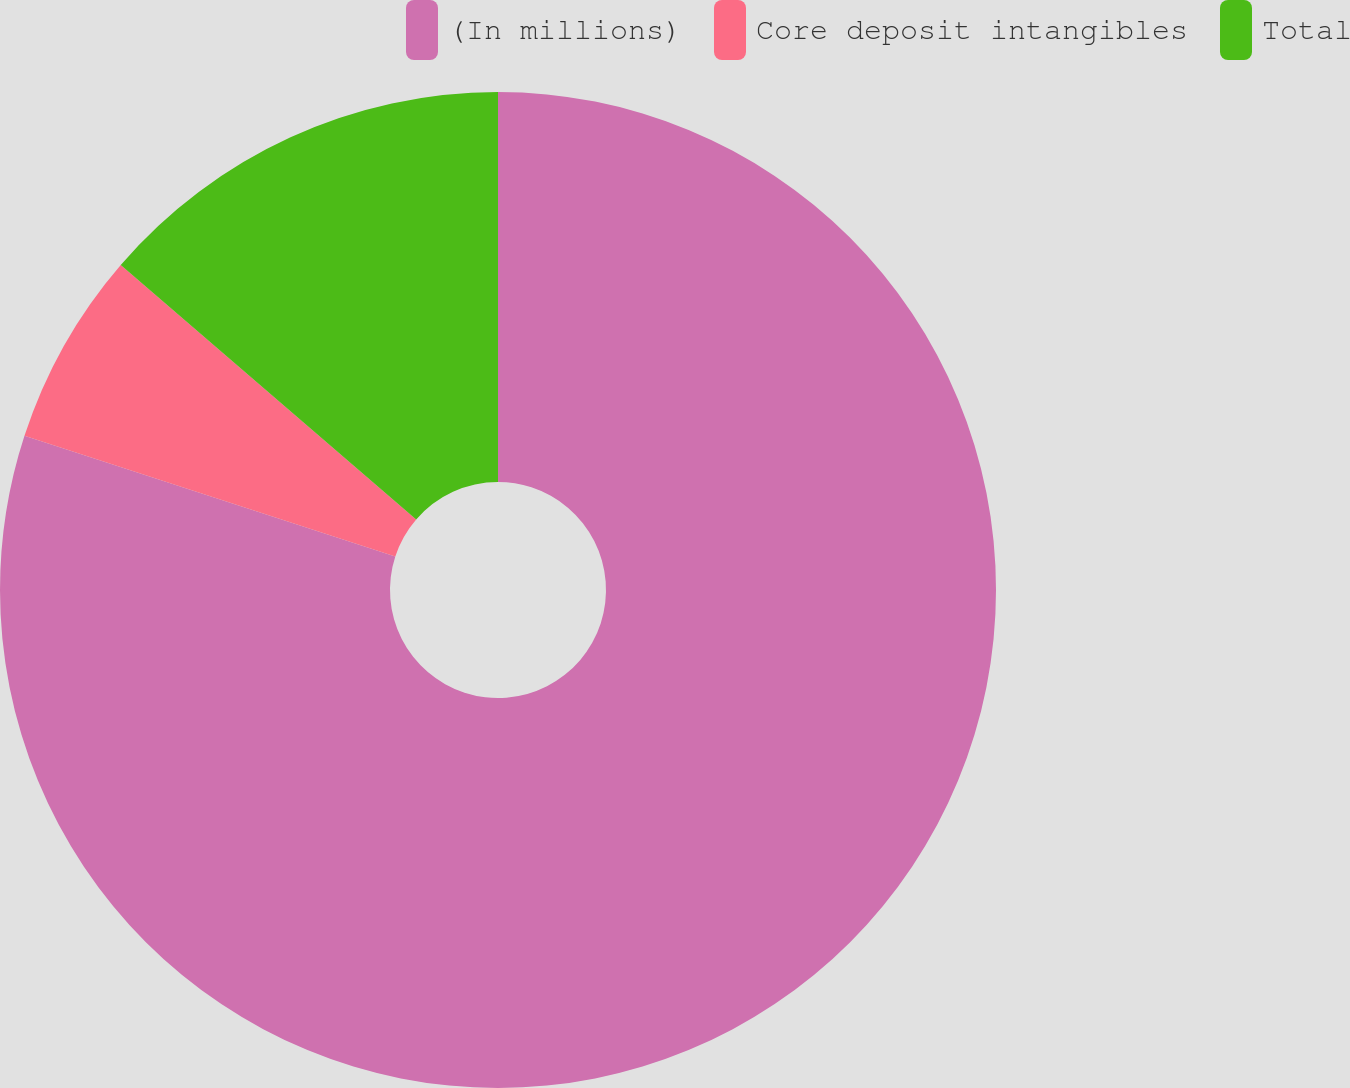Convert chart to OTSL. <chart><loc_0><loc_0><loc_500><loc_500><pie_chart><fcel>(In millions)<fcel>Core deposit intangibles<fcel>Total<nl><fcel>80.01%<fcel>6.31%<fcel>13.68%<nl></chart> 